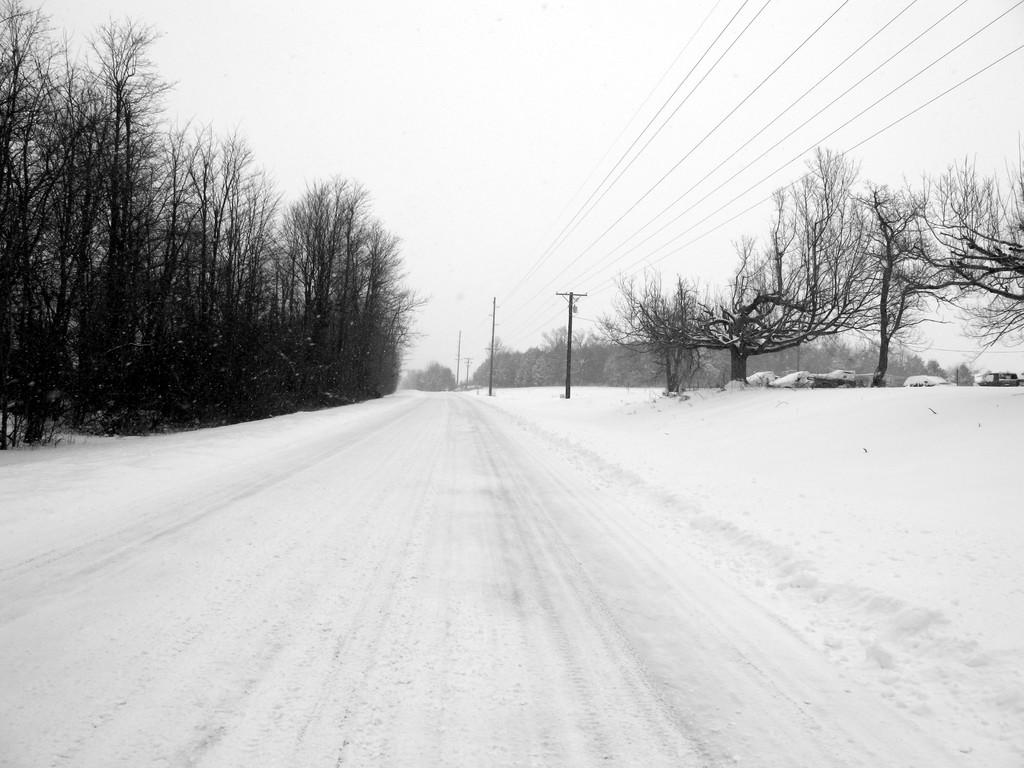What type of vegetation can be seen in the image? There are trees in the image. What is attached to the poles in the image? Wires are attached to poles in the image. What is the weather like in the image? There is snow visible in the image, indicating a cold or wintery weather. What is visible in the background of the image? The sky is visible in the background of the image. What is the color scheme of the image? The image is black and white in color. How many pies are being sold at the credit store in the image? There are no pies or credit stores present in the image. What type of shoes are the feet wearing in the image? There are no feet or shoes visible in the image. 